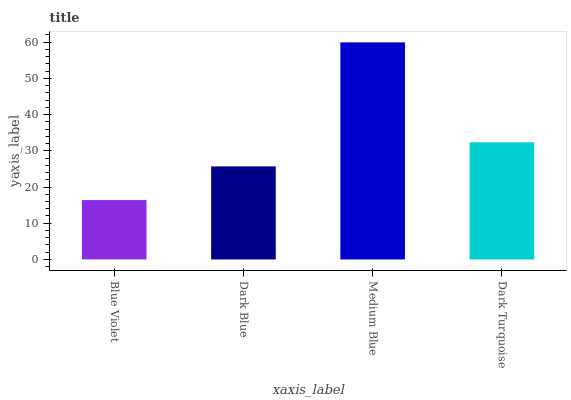Is Blue Violet the minimum?
Answer yes or no. Yes. Is Medium Blue the maximum?
Answer yes or no. Yes. Is Dark Blue the minimum?
Answer yes or no. No. Is Dark Blue the maximum?
Answer yes or no. No. Is Dark Blue greater than Blue Violet?
Answer yes or no. Yes. Is Blue Violet less than Dark Blue?
Answer yes or no. Yes. Is Blue Violet greater than Dark Blue?
Answer yes or no. No. Is Dark Blue less than Blue Violet?
Answer yes or no. No. Is Dark Turquoise the high median?
Answer yes or no. Yes. Is Dark Blue the low median?
Answer yes or no. Yes. Is Medium Blue the high median?
Answer yes or no. No. Is Dark Turquoise the low median?
Answer yes or no. No. 